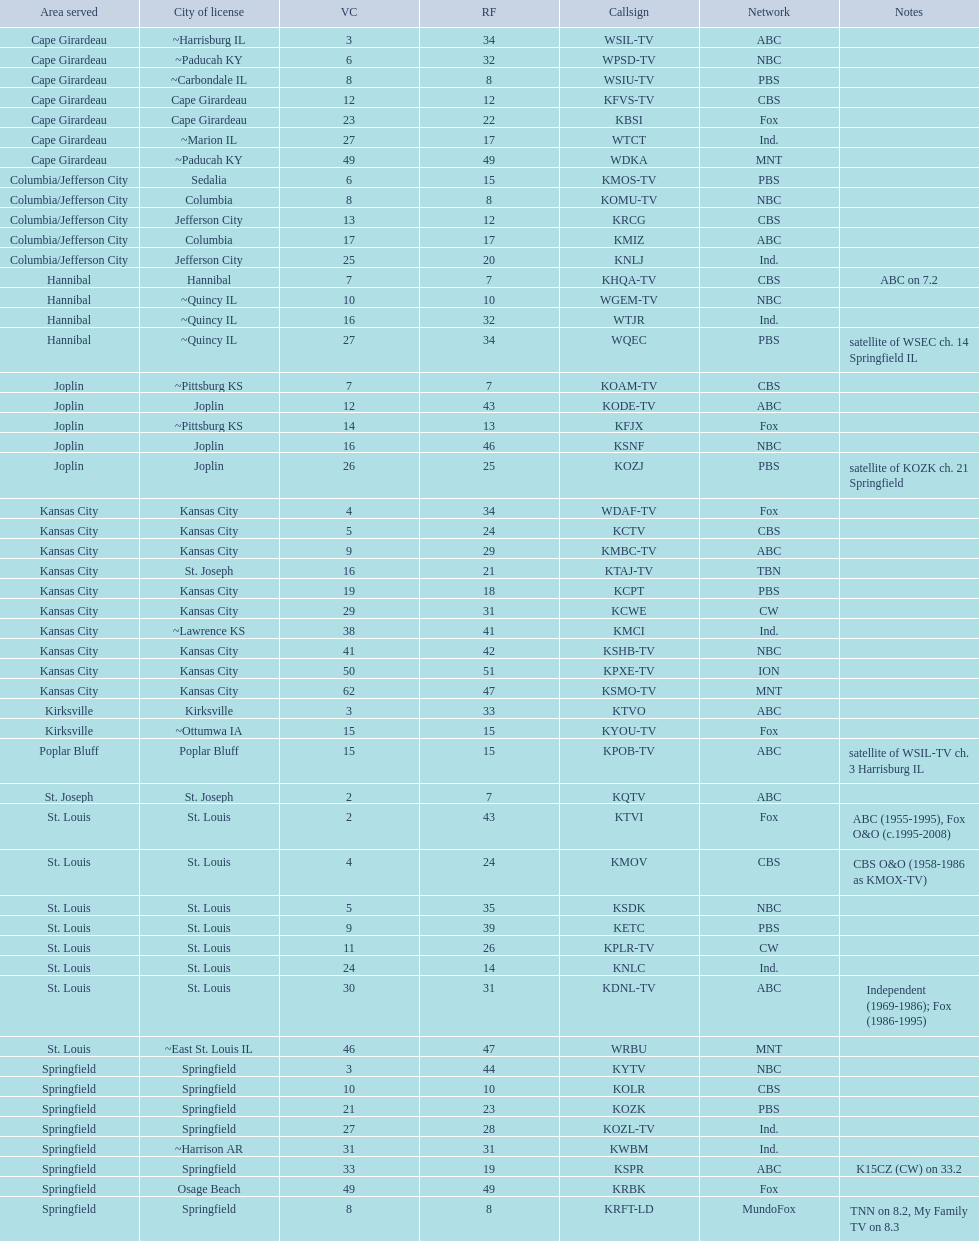What is the combined number of stations operating in the cape girardeau vicinity? 7. Parse the table in full. {'header': ['Area served', 'City of license', 'VC', 'RF', 'Callsign', 'Network', 'Notes'], 'rows': [['Cape Girardeau', '~Harrisburg IL', '3', '34', 'WSIL-TV', 'ABC', ''], ['Cape Girardeau', '~Paducah KY', '6', '32', 'WPSD-TV', 'NBC', ''], ['Cape Girardeau', '~Carbondale IL', '8', '8', 'WSIU-TV', 'PBS', ''], ['Cape Girardeau', 'Cape Girardeau', '12', '12', 'KFVS-TV', 'CBS', ''], ['Cape Girardeau', 'Cape Girardeau', '23', '22', 'KBSI', 'Fox', ''], ['Cape Girardeau', '~Marion IL', '27', '17', 'WTCT', 'Ind.', ''], ['Cape Girardeau', '~Paducah KY', '49', '49', 'WDKA', 'MNT', ''], ['Columbia/Jefferson City', 'Sedalia', '6', '15', 'KMOS-TV', 'PBS', ''], ['Columbia/Jefferson City', 'Columbia', '8', '8', 'KOMU-TV', 'NBC', ''], ['Columbia/Jefferson City', 'Jefferson City', '13', '12', 'KRCG', 'CBS', ''], ['Columbia/Jefferson City', 'Columbia', '17', '17', 'KMIZ', 'ABC', ''], ['Columbia/Jefferson City', 'Jefferson City', '25', '20', 'KNLJ', 'Ind.', ''], ['Hannibal', 'Hannibal', '7', '7', 'KHQA-TV', 'CBS', 'ABC on 7.2'], ['Hannibal', '~Quincy IL', '10', '10', 'WGEM-TV', 'NBC', ''], ['Hannibal', '~Quincy IL', '16', '32', 'WTJR', 'Ind.', ''], ['Hannibal', '~Quincy IL', '27', '34', 'WQEC', 'PBS', 'satellite of WSEC ch. 14 Springfield IL'], ['Joplin', '~Pittsburg KS', '7', '7', 'KOAM-TV', 'CBS', ''], ['Joplin', 'Joplin', '12', '43', 'KODE-TV', 'ABC', ''], ['Joplin', '~Pittsburg KS', '14', '13', 'KFJX', 'Fox', ''], ['Joplin', 'Joplin', '16', '46', 'KSNF', 'NBC', ''], ['Joplin', 'Joplin', '26', '25', 'KOZJ', 'PBS', 'satellite of KOZK ch. 21 Springfield'], ['Kansas City', 'Kansas City', '4', '34', 'WDAF-TV', 'Fox', ''], ['Kansas City', 'Kansas City', '5', '24', 'KCTV', 'CBS', ''], ['Kansas City', 'Kansas City', '9', '29', 'KMBC-TV', 'ABC', ''], ['Kansas City', 'St. Joseph', '16', '21', 'KTAJ-TV', 'TBN', ''], ['Kansas City', 'Kansas City', '19', '18', 'KCPT', 'PBS', ''], ['Kansas City', 'Kansas City', '29', '31', 'KCWE', 'CW', ''], ['Kansas City', '~Lawrence KS', '38', '41', 'KMCI', 'Ind.', ''], ['Kansas City', 'Kansas City', '41', '42', 'KSHB-TV', 'NBC', ''], ['Kansas City', 'Kansas City', '50', '51', 'KPXE-TV', 'ION', ''], ['Kansas City', 'Kansas City', '62', '47', 'KSMO-TV', 'MNT', ''], ['Kirksville', 'Kirksville', '3', '33', 'KTVO', 'ABC', ''], ['Kirksville', '~Ottumwa IA', '15', '15', 'KYOU-TV', 'Fox', ''], ['Poplar Bluff', 'Poplar Bluff', '15', '15', 'KPOB-TV', 'ABC', 'satellite of WSIL-TV ch. 3 Harrisburg IL'], ['St. Joseph', 'St. Joseph', '2', '7', 'KQTV', 'ABC', ''], ['St. Louis', 'St. Louis', '2', '43', 'KTVI', 'Fox', 'ABC (1955-1995), Fox O&O (c.1995-2008)'], ['St. Louis', 'St. Louis', '4', '24', 'KMOV', 'CBS', 'CBS O&O (1958-1986 as KMOX-TV)'], ['St. Louis', 'St. Louis', '5', '35', 'KSDK', 'NBC', ''], ['St. Louis', 'St. Louis', '9', '39', 'KETC', 'PBS', ''], ['St. Louis', 'St. Louis', '11', '26', 'KPLR-TV', 'CW', ''], ['St. Louis', 'St. Louis', '24', '14', 'KNLC', 'Ind.', ''], ['St. Louis', 'St. Louis', '30', '31', 'KDNL-TV', 'ABC', 'Independent (1969-1986); Fox (1986-1995)'], ['St. Louis', '~East St. Louis IL', '46', '47', 'WRBU', 'MNT', ''], ['Springfield', 'Springfield', '3', '44', 'KYTV', 'NBC', ''], ['Springfield', 'Springfield', '10', '10', 'KOLR', 'CBS', ''], ['Springfield', 'Springfield', '21', '23', 'KOZK', 'PBS', ''], ['Springfield', 'Springfield', '27', '28', 'KOZL-TV', 'Ind.', ''], ['Springfield', '~Harrison AR', '31', '31', 'KWBM', 'Ind.', ''], ['Springfield', 'Springfield', '33', '19', 'KSPR', 'ABC', 'K15CZ (CW) on 33.2'], ['Springfield', 'Osage Beach', '49', '49', 'KRBK', 'Fox', ''], ['Springfield', 'Springfield', '8', '8', 'KRFT-LD', 'MundoFox', 'TNN on 8.2, My Family TV on 8.3']]} 